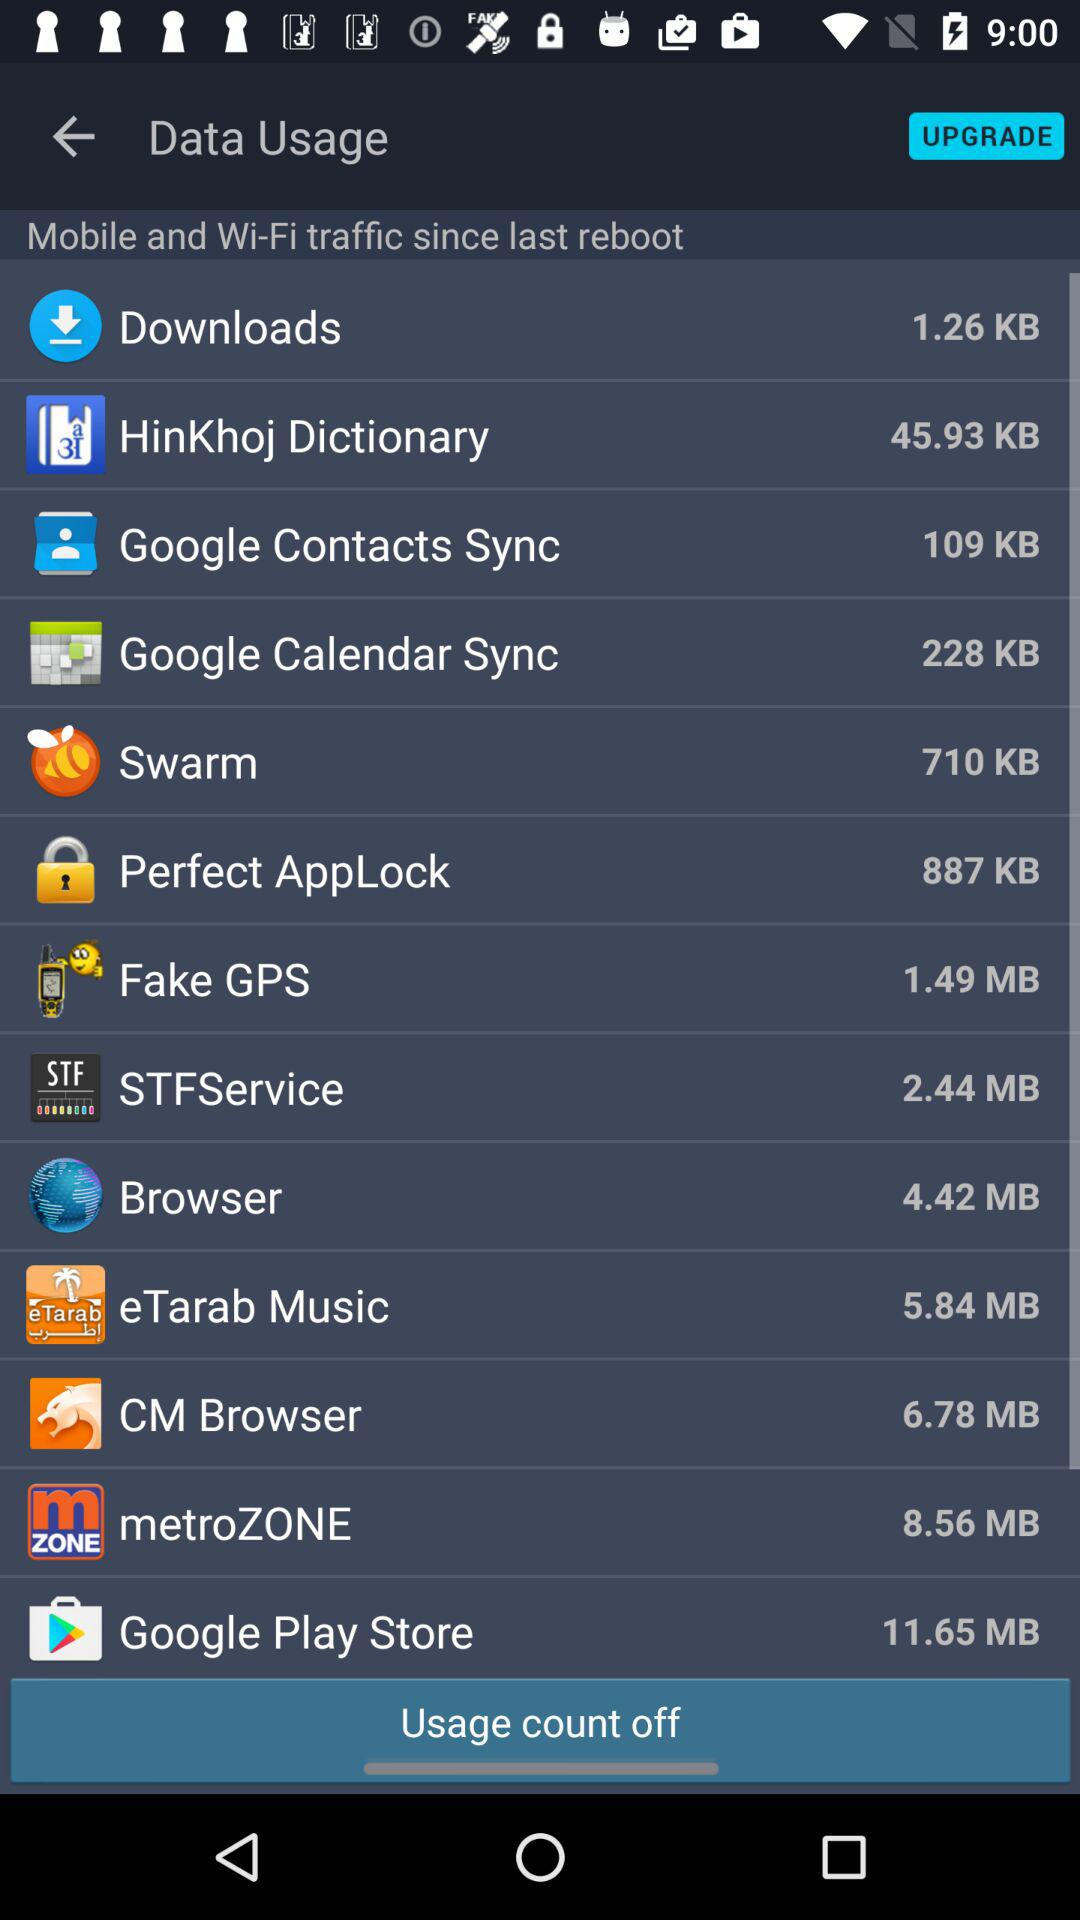What is the data usage size of the "Browser" app? The data usage size of the "Browser" app is 4.42 MB. 